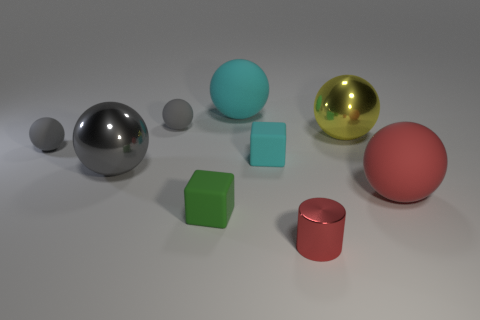How many gray balls must be subtracted to get 1 gray balls? 2 Subtract all big matte spheres. How many spheres are left? 4 Subtract all cyan blocks. How many gray balls are left? 3 Subtract all cyan cubes. How many cubes are left? 1 Subtract 1 blocks. How many blocks are left? 1 Add 1 big cyan rubber spheres. How many objects exist? 10 Add 5 big gray things. How many big gray things are left? 6 Add 6 red matte spheres. How many red matte spheres exist? 7 Subtract 1 red cylinders. How many objects are left? 8 Subtract all spheres. How many objects are left? 3 